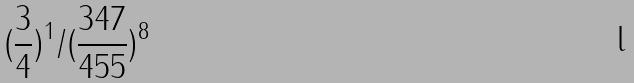<formula> <loc_0><loc_0><loc_500><loc_500>( \frac { 3 } { 4 } ) ^ { 1 } / ( \frac { 3 4 7 } { 4 5 5 } ) ^ { 8 }</formula> 